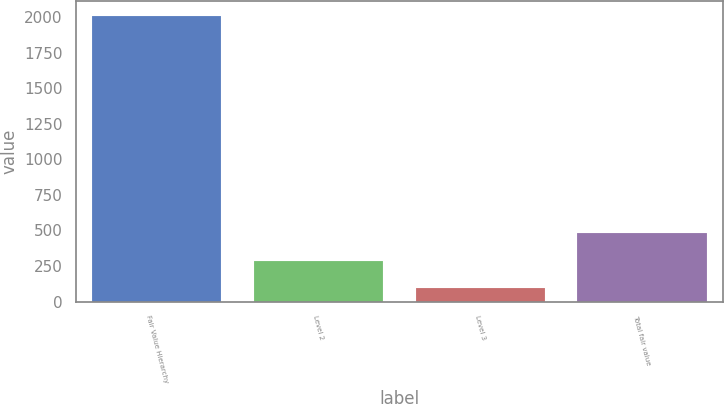Convert chart to OTSL. <chart><loc_0><loc_0><loc_500><loc_500><bar_chart><fcel>Fair Value Hierarchy<fcel>Level 2<fcel>Level 3<fcel>Total fair value<nl><fcel>2013<fcel>287.79<fcel>96.1<fcel>479.48<nl></chart> 